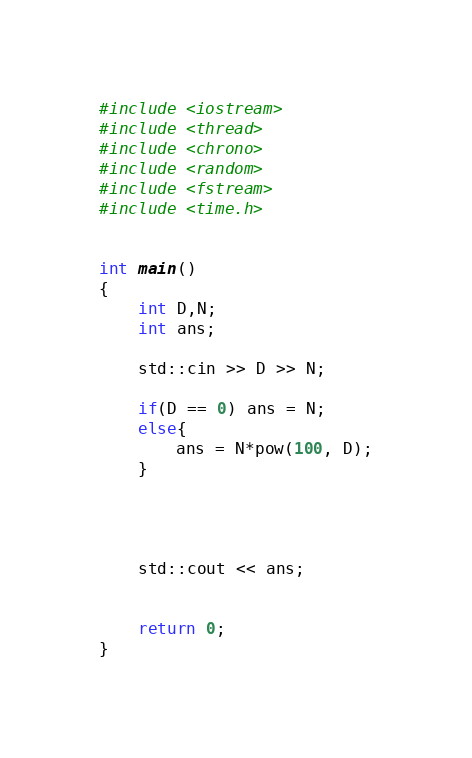<code> <loc_0><loc_0><loc_500><loc_500><_C++_>#include <iostream>
#include <thread>
#include <chrono>
#include <random>
#include <fstream>
#include <time.h>


int main()
{
    int D,N;
    int ans;

    std::cin >> D >> N;

    if(D == 0) ans = N;
    else{
        ans = N*pow(100, D);
    }




    std::cout << ans;


    return 0;
}</code> 